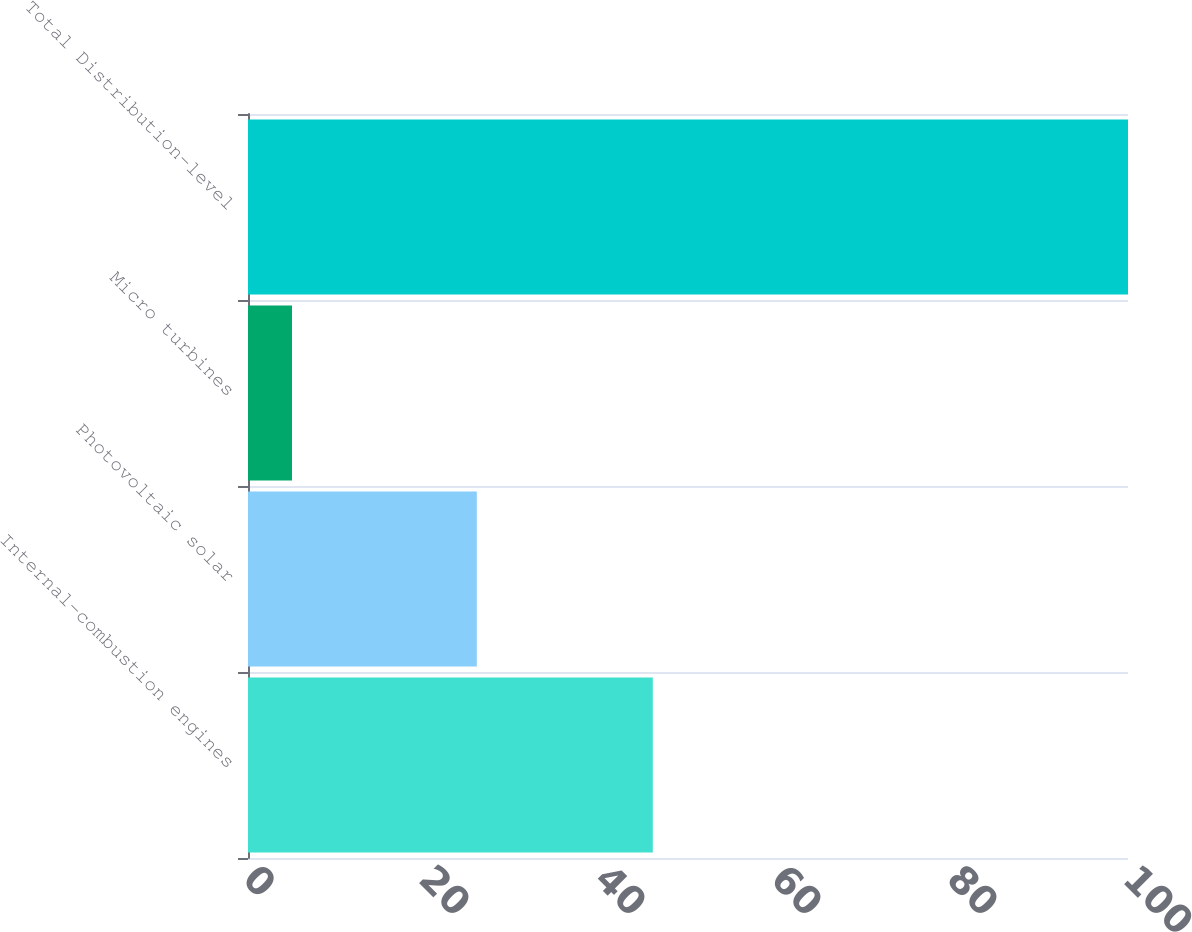<chart> <loc_0><loc_0><loc_500><loc_500><bar_chart><fcel>Internal-combustion engines<fcel>Photovoltaic solar<fcel>Micro turbines<fcel>Total Distribution-level<nl><fcel>46<fcel>26<fcel>5<fcel>100<nl></chart> 